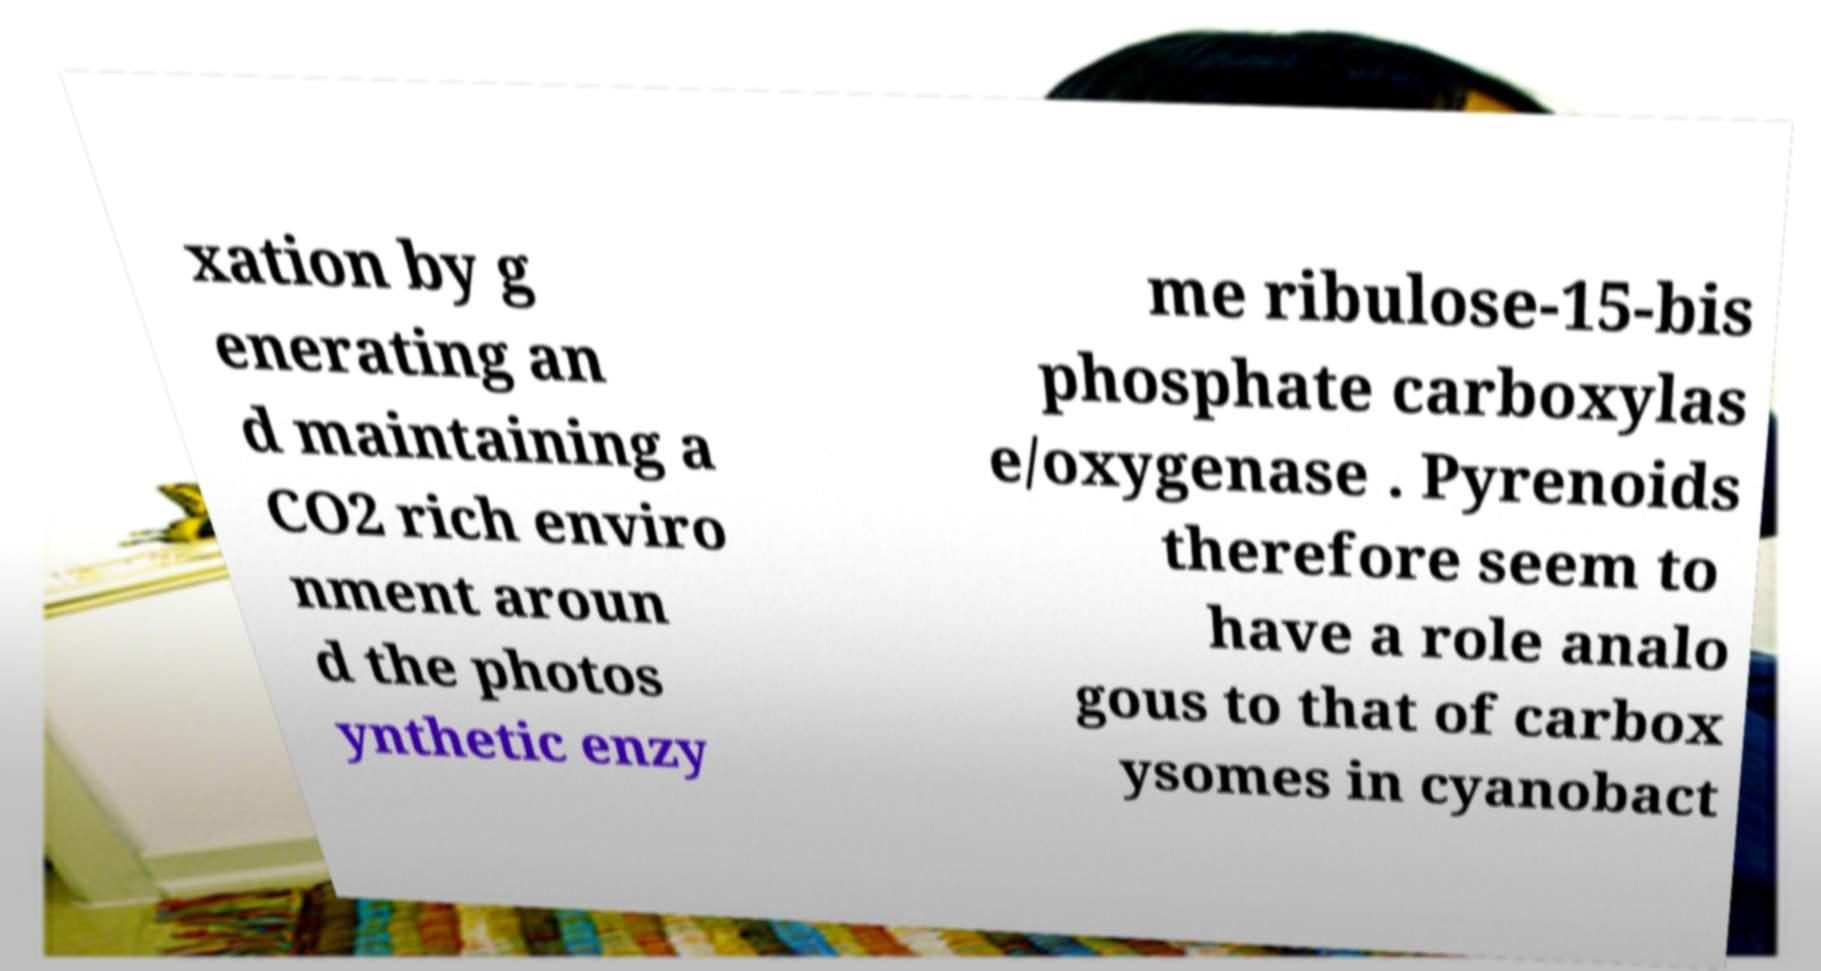Can you accurately transcribe the text from the provided image for me? xation by g enerating an d maintaining a CO2 rich enviro nment aroun d the photos ynthetic enzy me ribulose-15-bis phosphate carboxylas e/oxygenase . Pyrenoids therefore seem to have a role analo gous to that of carbox ysomes in cyanobact 